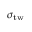Convert formula to latex. <formula><loc_0><loc_0><loc_500><loc_500>\sigma _ { t w }</formula> 